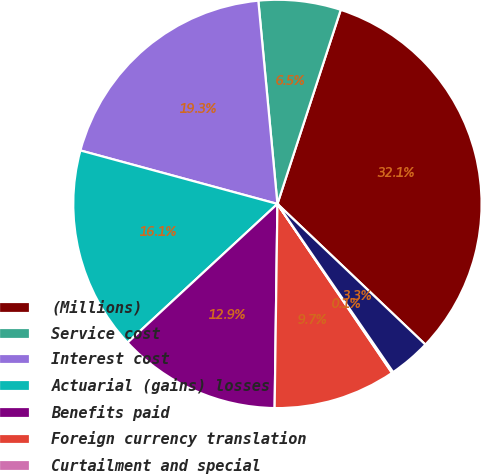<chart> <loc_0><loc_0><loc_500><loc_500><pie_chart><fcel>(Millions)<fcel>Service cost<fcel>Interest cost<fcel>Actuarial (gains) losses<fcel>Benefits paid<fcel>Foreign currency translation<fcel>Curtailment and special<fcel>Accounts payable and accrued<nl><fcel>32.08%<fcel>6.51%<fcel>19.29%<fcel>16.1%<fcel>12.9%<fcel>9.7%<fcel>0.11%<fcel>3.31%<nl></chart> 